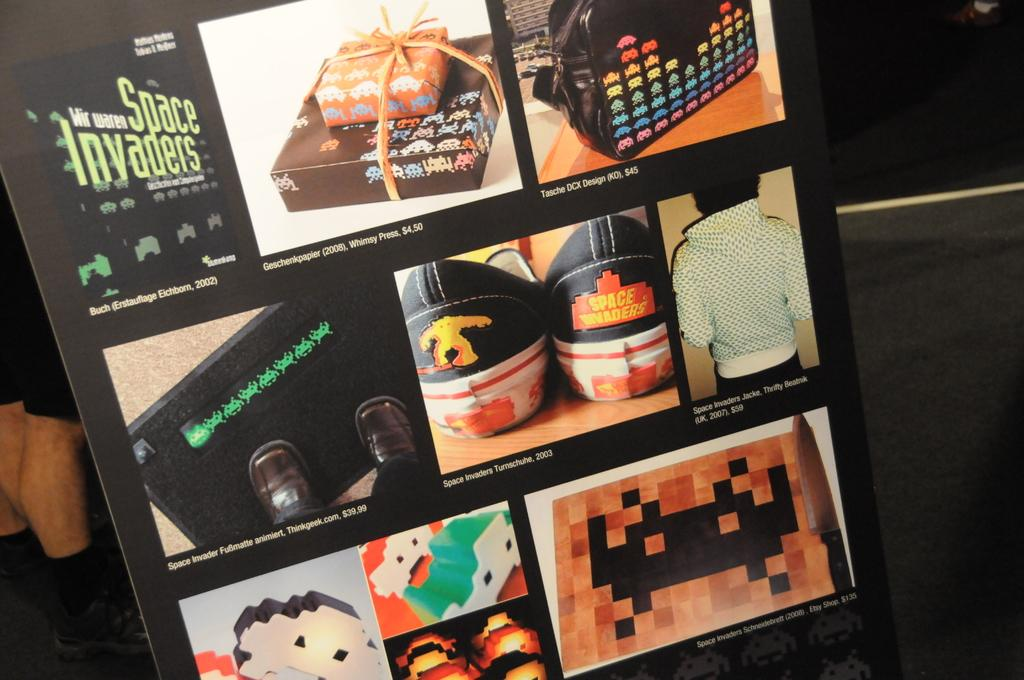<image>
Provide a brief description of the given image. A poster of Wir waren Space Invades with some picture of clothes and shoes. 